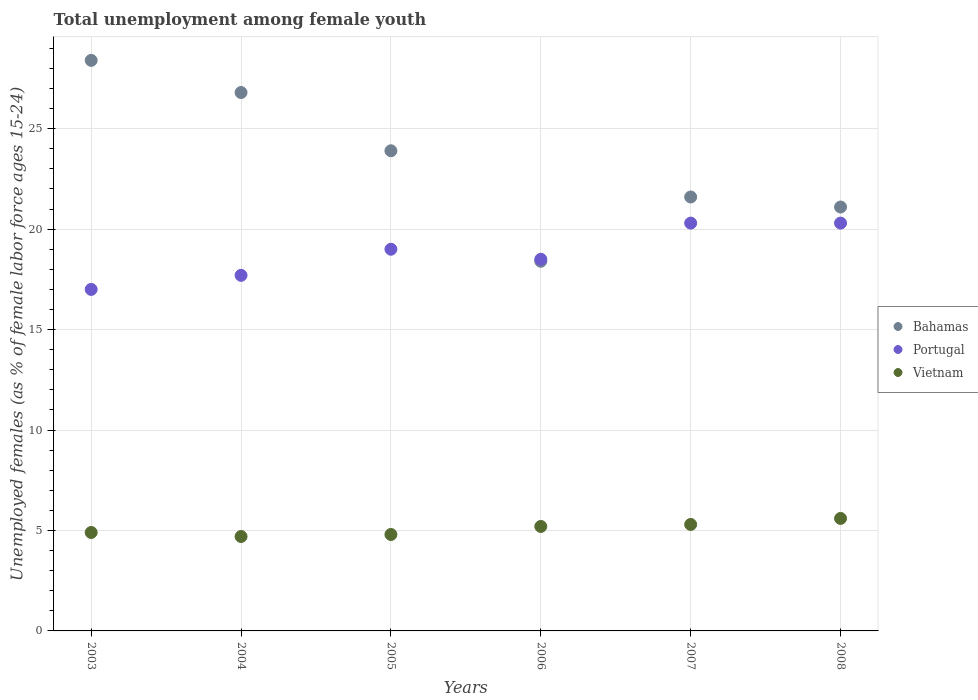What is the percentage of unemployed females in in Portugal in 2003?
Your answer should be compact. 17. Across all years, what is the maximum percentage of unemployed females in in Vietnam?
Keep it short and to the point. 5.6. Across all years, what is the minimum percentage of unemployed females in in Bahamas?
Give a very brief answer. 18.4. In which year was the percentage of unemployed females in in Vietnam maximum?
Your response must be concise. 2008. In which year was the percentage of unemployed females in in Vietnam minimum?
Your response must be concise. 2004. What is the total percentage of unemployed females in in Vietnam in the graph?
Offer a terse response. 30.5. What is the difference between the percentage of unemployed females in in Vietnam in 2004 and that in 2007?
Offer a very short reply. -0.6. What is the difference between the percentage of unemployed females in in Vietnam in 2004 and the percentage of unemployed females in in Portugal in 2008?
Your response must be concise. -15.6. What is the average percentage of unemployed females in in Portugal per year?
Make the answer very short. 18.8. In the year 2008, what is the difference between the percentage of unemployed females in in Bahamas and percentage of unemployed females in in Portugal?
Provide a succinct answer. 0.8. In how many years, is the percentage of unemployed females in in Bahamas greater than 23 %?
Give a very brief answer. 3. What is the ratio of the percentage of unemployed females in in Vietnam in 2004 to that in 2008?
Keep it short and to the point. 0.84. Is the percentage of unemployed females in in Bahamas in 2004 less than that in 2005?
Ensure brevity in your answer.  No. What is the difference between the highest and the second highest percentage of unemployed females in in Bahamas?
Provide a short and direct response. 1.6. What is the difference between the highest and the lowest percentage of unemployed females in in Portugal?
Your answer should be compact. 3.3. Is it the case that in every year, the sum of the percentage of unemployed females in in Vietnam and percentage of unemployed females in in Portugal  is greater than the percentage of unemployed females in in Bahamas?
Offer a terse response. No. Does the percentage of unemployed females in in Portugal monotonically increase over the years?
Make the answer very short. No. Is the percentage of unemployed females in in Bahamas strictly greater than the percentage of unemployed females in in Portugal over the years?
Your answer should be compact. No. How many dotlines are there?
Make the answer very short. 3. How many years are there in the graph?
Provide a succinct answer. 6. Does the graph contain grids?
Keep it short and to the point. Yes. How are the legend labels stacked?
Provide a short and direct response. Vertical. What is the title of the graph?
Give a very brief answer. Total unemployment among female youth. Does "Kyrgyz Republic" appear as one of the legend labels in the graph?
Make the answer very short. No. What is the label or title of the X-axis?
Make the answer very short. Years. What is the label or title of the Y-axis?
Offer a very short reply. Unemployed females (as % of female labor force ages 15-24). What is the Unemployed females (as % of female labor force ages 15-24) of Bahamas in 2003?
Your answer should be very brief. 28.4. What is the Unemployed females (as % of female labor force ages 15-24) of Portugal in 2003?
Offer a terse response. 17. What is the Unemployed females (as % of female labor force ages 15-24) of Vietnam in 2003?
Provide a succinct answer. 4.9. What is the Unemployed females (as % of female labor force ages 15-24) in Bahamas in 2004?
Your answer should be very brief. 26.8. What is the Unemployed females (as % of female labor force ages 15-24) in Portugal in 2004?
Your answer should be compact. 17.7. What is the Unemployed females (as % of female labor force ages 15-24) in Vietnam in 2004?
Offer a terse response. 4.7. What is the Unemployed females (as % of female labor force ages 15-24) of Bahamas in 2005?
Offer a terse response. 23.9. What is the Unemployed females (as % of female labor force ages 15-24) in Vietnam in 2005?
Make the answer very short. 4.8. What is the Unemployed females (as % of female labor force ages 15-24) in Bahamas in 2006?
Your response must be concise. 18.4. What is the Unemployed females (as % of female labor force ages 15-24) in Portugal in 2006?
Make the answer very short. 18.5. What is the Unemployed females (as % of female labor force ages 15-24) of Vietnam in 2006?
Your answer should be compact. 5.2. What is the Unemployed females (as % of female labor force ages 15-24) in Bahamas in 2007?
Provide a succinct answer. 21.6. What is the Unemployed females (as % of female labor force ages 15-24) in Portugal in 2007?
Keep it short and to the point. 20.3. What is the Unemployed females (as % of female labor force ages 15-24) of Vietnam in 2007?
Your response must be concise. 5.3. What is the Unemployed females (as % of female labor force ages 15-24) in Bahamas in 2008?
Ensure brevity in your answer.  21.1. What is the Unemployed females (as % of female labor force ages 15-24) of Portugal in 2008?
Ensure brevity in your answer.  20.3. What is the Unemployed females (as % of female labor force ages 15-24) in Vietnam in 2008?
Keep it short and to the point. 5.6. Across all years, what is the maximum Unemployed females (as % of female labor force ages 15-24) of Bahamas?
Give a very brief answer. 28.4. Across all years, what is the maximum Unemployed females (as % of female labor force ages 15-24) in Portugal?
Your answer should be very brief. 20.3. Across all years, what is the maximum Unemployed females (as % of female labor force ages 15-24) in Vietnam?
Offer a terse response. 5.6. Across all years, what is the minimum Unemployed females (as % of female labor force ages 15-24) in Bahamas?
Your answer should be very brief. 18.4. Across all years, what is the minimum Unemployed females (as % of female labor force ages 15-24) in Vietnam?
Ensure brevity in your answer.  4.7. What is the total Unemployed females (as % of female labor force ages 15-24) in Bahamas in the graph?
Ensure brevity in your answer.  140.2. What is the total Unemployed females (as % of female labor force ages 15-24) of Portugal in the graph?
Offer a terse response. 112.8. What is the total Unemployed females (as % of female labor force ages 15-24) of Vietnam in the graph?
Keep it short and to the point. 30.5. What is the difference between the Unemployed females (as % of female labor force ages 15-24) of Portugal in 2003 and that in 2004?
Offer a very short reply. -0.7. What is the difference between the Unemployed females (as % of female labor force ages 15-24) of Vietnam in 2003 and that in 2005?
Keep it short and to the point. 0.1. What is the difference between the Unemployed females (as % of female labor force ages 15-24) of Portugal in 2003 and that in 2006?
Offer a very short reply. -1.5. What is the difference between the Unemployed females (as % of female labor force ages 15-24) of Vietnam in 2003 and that in 2007?
Your answer should be very brief. -0.4. What is the difference between the Unemployed females (as % of female labor force ages 15-24) of Portugal in 2003 and that in 2008?
Give a very brief answer. -3.3. What is the difference between the Unemployed females (as % of female labor force ages 15-24) of Vietnam in 2003 and that in 2008?
Ensure brevity in your answer.  -0.7. What is the difference between the Unemployed females (as % of female labor force ages 15-24) of Portugal in 2004 and that in 2005?
Provide a succinct answer. -1.3. What is the difference between the Unemployed females (as % of female labor force ages 15-24) of Bahamas in 2004 and that in 2006?
Make the answer very short. 8.4. What is the difference between the Unemployed females (as % of female labor force ages 15-24) of Portugal in 2004 and that in 2006?
Make the answer very short. -0.8. What is the difference between the Unemployed females (as % of female labor force ages 15-24) in Bahamas in 2004 and that in 2007?
Ensure brevity in your answer.  5.2. What is the difference between the Unemployed females (as % of female labor force ages 15-24) in Portugal in 2004 and that in 2007?
Offer a terse response. -2.6. What is the difference between the Unemployed females (as % of female labor force ages 15-24) of Vietnam in 2004 and that in 2007?
Offer a very short reply. -0.6. What is the difference between the Unemployed females (as % of female labor force ages 15-24) in Bahamas in 2004 and that in 2008?
Your answer should be very brief. 5.7. What is the difference between the Unemployed females (as % of female labor force ages 15-24) in Vietnam in 2004 and that in 2008?
Offer a terse response. -0.9. What is the difference between the Unemployed females (as % of female labor force ages 15-24) in Bahamas in 2005 and that in 2006?
Offer a very short reply. 5.5. What is the difference between the Unemployed females (as % of female labor force ages 15-24) in Bahamas in 2005 and that in 2007?
Make the answer very short. 2.3. What is the difference between the Unemployed females (as % of female labor force ages 15-24) of Portugal in 2005 and that in 2007?
Offer a very short reply. -1.3. What is the difference between the Unemployed females (as % of female labor force ages 15-24) in Bahamas in 2005 and that in 2008?
Your response must be concise. 2.8. What is the difference between the Unemployed females (as % of female labor force ages 15-24) in Portugal in 2005 and that in 2008?
Make the answer very short. -1.3. What is the difference between the Unemployed females (as % of female labor force ages 15-24) of Vietnam in 2005 and that in 2008?
Provide a succinct answer. -0.8. What is the difference between the Unemployed females (as % of female labor force ages 15-24) in Portugal in 2006 and that in 2007?
Offer a terse response. -1.8. What is the difference between the Unemployed females (as % of female labor force ages 15-24) in Vietnam in 2006 and that in 2007?
Make the answer very short. -0.1. What is the difference between the Unemployed females (as % of female labor force ages 15-24) in Vietnam in 2006 and that in 2008?
Give a very brief answer. -0.4. What is the difference between the Unemployed females (as % of female labor force ages 15-24) in Bahamas in 2007 and that in 2008?
Ensure brevity in your answer.  0.5. What is the difference between the Unemployed females (as % of female labor force ages 15-24) in Bahamas in 2003 and the Unemployed females (as % of female labor force ages 15-24) in Portugal in 2004?
Ensure brevity in your answer.  10.7. What is the difference between the Unemployed females (as % of female labor force ages 15-24) in Bahamas in 2003 and the Unemployed females (as % of female labor force ages 15-24) in Vietnam in 2004?
Give a very brief answer. 23.7. What is the difference between the Unemployed females (as % of female labor force ages 15-24) in Bahamas in 2003 and the Unemployed females (as % of female labor force ages 15-24) in Vietnam in 2005?
Provide a short and direct response. 23.6. What is the difference between the Unemployed females (as % of female labor force ages 15-24) in Portugal in 2003 and the Unemployed females (as % of female labor force ages 15-24) in Vietnam in 2005?
Your answer should be compact. 12.2. What is the difference between the Unemployed females (as % of female labor force ages 15-24) of Bahamas in 2003 and the Unemployed females (as % of female labor force ages 15-24) of Portugal in 2006?
Offer a terse response. 9.9. What is the difference between the Unemployed females (as % of female labor force ages 15-24) in Bahamas in 2003 and the Unemployed females (as % of female labor force ages 15-24) in Vietnam in 2006?
Offer a very short reply. 23.2. What is the difference between the Unemployed females (as % of female labor force ages 15-24) in Bahamas in 2003 and the Unemployed females (as % of female labor force ages 15-24) in Portugal in 2007?
Your answer should be compact. 8.1. What is the difference between the Unemployed females (as % of female labor force ages 15-24) of Bahamas in 2003 and the Unemployed females (as % of female labor force ages 15-24) of Vietnam in 2007?
Ensure brevity in your answer.  23.1. What is the difference between the Unemployed females (as % of female labor force ages 15-24) in Bahamas in 2003 and the Unemployed females (as % of female labor force ages 15-24) in Vietnam in 2008?
Offer a very short reply. 22.8. What is the difference between the Unemployed females (as % of female labor force ages 15-24) of Portugal in 2003 and the Unemployed females (as % of female labor force ages 15-24) of Vietnam in 2008?
Your answer should be very brief. 11.4. What is the difference between the Unemployed females (as % of female labor force ages 15-24) of Bahamas in 2004 and the Unemployed females (as % of female labor force ages 15-24) of Portugal in 2005?
Make the answer very short. 7.8. What is the difference between the Unemployed females (as % of female labor force ages 15-24) in Bahamas in 2004 and the Unemployed females (as % of female labor force ages 15-24) in Vietnam in 2006?
Provide a short and direct response. 21.6. What is the difference between the Unemployed females (as % of female labor force ages 15-24) of Portugal in 2004 and the Unemployed females (as % of female labor force ages 15-24) of Vietnam in 2006?
Offer a terse response. 12.5. What is the difference between the Unemployed females (as % of female labor force ages 15-24) in Bahamas in 2004 and the Unemployed females (as % of female labor force ages 15-24) in Portugal in 2007?
Offer a terse response. 6.5. What is the difference between the Unemployed females (as % of female labor force ages 15-24) of Bahamas in 2004 and the Unemployed females (as % of female labor force ages 15-24) of Vietnam in 2008?
Your answer should be compact. 21.2. What is the difference between the Unemployed females (as % of female labor force ages 15-24) of Bahamas in 2005 and the Unemployed females (as % of female labor force ages 15-24) of Portugal in 2006?
Offer a terse response. 5.4. What is the difference between the Unemployed females (as % of female labor force ages 15-24) of Portugal in 2005 and the Unemployed females (as % of female labor force ages 15-24) of Vietnam in 2006?
Your answer should be compact. 13.8. What is the difference between the Unemployed females (as % of female labor force ages 15-24) of Bahamas in 2005 and the Unemployed females (as % of female labor force ages 15-24) of Vietnam in 2007?
Give a very brief answer. 18.6. What is the difference between the Unemployed females (as % of female labor force ages 15-24) in Bahamas in 2005 and the Unemployed females (as % of female labor force ages 15-24) in Portugal in 2008?
Provide a short and direct response. 3.6. What is the difference between the Unemployed females (as % of female labor force ages 15-24) of Bahamas in 2006 and the Unemployed females (as % of female labor force ages 15-24) of Vietnam in 2007?
Your answer should be compact. 13.1. What is the difference between the Unemployed females (as % of female labor force ages 15-24) in Bahamas in 2006 and the Unemployed females (as % of female labor force ages 15-24) in Portugal in 2008?
Offer a terse response. -1.9. What is the difference between the Unemployed females (as % of female labor force ages 15-24) of Bahamas in 2006 and the Unemployed females (as % of female labor force ages 15-24) of Vietnam in 2008?
Provide a succinct answer. 12.8. What is the difference between the Unemployed females (as % of female labor force ages 15-24) in Bahamas in 2007 and the Unemployed females (as % of female labor force ages 15-24) in Portugal in 2008?
Your answer should be very brief. 1.3. What is the average Unemployed females (as % of female labor force ages 15-24) in Bahamas per year?
Give a very brief answer. 23.37. What is the average Unemployed females (as % of female labor force ages 15-24) in Portugal per year?
Keep it short and to the point. 18.8. What is the average Unemployed females (as % of female labor force ages 15-24) of Vietnam per year?
Keep it short and to the point. 5.08. In the year 2003, what is the difference between the Unemployed females (as % of female labor force ages 15-24) in Bahamas and Unemployed females (as % of female labor force ages 15-24) in Portugal?
Give a very brief answer. 11.4. In the year 2003, what is the difference between the Unemployed females (as % of female labor force ages 15-24) in Bahamas and Unemployed females (as % of female labor force ages 15-24) in Vietnam?
Your response must be concise. 23.5. In the year 2004, what is the difference between the Unemployed females (as % of female labor force ages 15-24) of Bahamas and Unemployed females (as % of female labor force ages 15-24) of Vietnam?
Your answer should be compact. 22.1. In the year 2005, what is the difference between the Unemployed females (as % of female labor force ages 15-24) of Bahamas and Unemployed females (as % of female labor force ages 15-24) of Portugal?
Give a very brief answer. 4.9. In the year 2005, what is the difference between the Unemployed females (as % of female labor force ages 15-24) in Bahamas and Unemployed females (as % of female labor force ages 15-24) in Vietnam?
Your response must be concise. 19.1. In the year 2006, what is the difference between the Unemployed females (as % of female labor force ages 15-24) of Portugal and Unemployed females (as % of female labor force ages 15-24) of Vietnam?
Give a very brief answer. 13.3. In the year 2008, what is the difference between the Unemployed females (as % of female labor force ages 15-24) of Bahamas and Unemployed females (as % of female labor force ages 15-24) of Vietnam?
Your answer should be very brief. 15.5. In the year 2008, what is the difference between the Unemployed females (as % of female labor force ages 15-24) in Portugal and Unemployed females (as % of female labor force ages 15-24) in Vietnam?
Your response must be concise. 14.7. What is the ratio of the Unemployed females (as % of female labor force ages 15-24) in Bahamas in 2003 to that in 2004?
Give a very brief answer. 1.06. What is the ratio of the Unemployed females (as % of female labor force ages 15-24) of Portugal in 2003 to that in 2004?
Offer a terse response. 0.96. What is the ratio of the Unemployed females (as % of female labor force ages 15-24) of Vietnam in 2003 to that in 2004?
Offer a very short reply. 1.04. What is the ratio of the Unemployed females (as % of female labor force ages 15-24) of Bahamas in 2003 to that in 2005?
Provide a succinct answer. 1.19. What is the ratio of the Unemployed females (as % of female labor force ages 15-24) of Portugal in 2003 to that in 2005?
Offer a very short reply. 0.89. What is the ratio of the Unemployed females (as % of female labor force ages 15-24) in Vietnam in 2003 to that in 2005?
Offer a very short reply. 1.02. What is the ratio of the Unemployed females (as % of female labor force ages 15-24) of Bahamas in 2003 to that in 2006?
Your answer should be very brief. 1.54. What is the ratio of the Unemployed females (as % of female labor force ages 15-24) of Portugal in 2003 to that in 2006?
Make the answer very short. 0.92. What is the ratio of the Unemployed females (as % of female labor force ages 15-24) of Vietnam in 2003 to that in 2006?
Provide a succinct answer. 0.94. What is the ratio of the Unemployed females (as % of female labor force ages 15-24) in Bahamas in 2003 to that in 2007?
Offer a very short reply. 1.31. What is the ratio of the Unemployed females (as % of female labor force ages 15-24) of Portugal in 2003 to that in 2007?
Provide a succinct answer. 0.84. What is the ratio of the Unemployed females (as % of female labor force ages 15-24) in Vietnam in 2003 to that in 2007?
Ensure brevity in your answer.  0.92. What is the ratio of the Unemployed females (as % of female labor force ages 15-24) of Bahamas in 2003 to that in 2008?
Provide a succinct answer. 1.35. What is the ratio of the Unemployed females (as % of female labor force ages 15-24) of Portugal in 2003 to that in 2008?
Provide a succinct answer. 0.84. What is the ratio of the Unemployed females (as % of female labor force ages 15-24) of Vietnam in 2003 to that in 2008?
Your answer should be compact. 0.88. What is the ratio of the Unemployed females (as % of female labor force ages 15-24) in Bahamas in 2004 to that in 2005?
Your answer should be compact. 1.12. What is the ratio of the Unemployed females (as % of female labor force ages 15-24) in Portugal in 2004 to that in 2005?
Offer a terse response. 0.93. What is the ratio of the Unemployed females (as % of female labor force ages 15-24) of Vietnam in 2004 to that in 2005?
Keep it short and to the point. 0.98. What is the ratio of the Unemployed females (as % of female labor force ages 15-24) in Bahamas in 2004 to that in 2006?
Offer a very short reply. 1.46. What is the ratio of the Unemployed females (as % of female labor force ages 15-24) in Portugal in 2004 to that in 2006?
Offer a terse response. 0.96. What is the ratio of the Unemployed females (as % of female labor force ages 15-24) of Vietnam in 2004 to that in 2006?
Your answer should be very brief. 0.9. What is the ratio of the Unemployed females (as % of female labor force ages 15-24) in Bahamas in 2004 to that in 2007?
Ensure brevity in your answer.  1.24. What is the ratio of the Unemployed females (as % of female labor force ages 15-24) of Portugal in 2004 to that in 2007?
Offer a very short reply. 0.87. What is the ratio of the Unemployed females (as % of female labor force ages 15-24) of Vietnam in 2004 to that in 2007?
Offer a terse response. 0.89. What is the ratio of the Unemployed females (as % of female labor force ages 15-24) of Bahamas in 2004 to that in 2008?
Offer a very short reply. 1.27. What is the ratio of the Unemployed females (as % of female labor force ages 15-24) of Portugal in 2004 to that in 2008?
Your response must be concise. 0.87. What is the ratio of the Unemployed females (as % of female labor force ages 15-24) in Vietnam in 2004 to that in 2008?
Ensure brevity in your answer.  0.84. What is the ratio of the Unemployed females (as % of female labor force ages 15-24) of Bahamas in 2005 to that in 2006?
Offer a very short reply. 1.3. What is the ratio of the Unemployed females (as % of female labor force ages 15-24) of Portugal in 2005 to that in 2006?
Provide a short and direct response. 1.03. What is the ratio of the Unemployed females (as % of female labor force ages 15-24) in Bahamas in 2005 to that in 2007?
Ensure brevity in your answer.  1.11. What is the ratio of the Unemployed females (as % of female labor force ages 15-24) of Portugal in 2005 to that in 2007?
Keep it short and to the point. 0.94. What is the ratio of the Unemployed females (as % of female labor force ages 15-24) in Vietnam in 2005 to that in 2007?
Provide a short and direct response. 0.91. What is the ratio of the Unemployed females (as % of female labor force ages 15-24) of Bahamas in 2005 to that in 2008?
Make the answer very short. 1.13. What is the ratio of the Unemployed females (as % of female labor force ages 15-24) of Portugal in 2005 to that in 2008?
Make the answer very short. 0.94. What is the ratio of the Unemployed females (as % of female labor force ages 15-24) in Bahamas in 2006 to that in 2007?
Make the answer very short. 0.85. What is the ratio of the Unemployed females (as % of female labor force ages 15-24) in Portugal in 2006 to that in 2007?
Offer a very short reply. 0.91. What is the ratio of the Unemployed females (as % of female labor force ages 15-24) in Vietnam in 2006 to that in 2007?
Your response must be concise. 0.98. What is the ratio of the Unemployed females (as % of female labor force ages 15-24) in Bahamas in 2006 to that in 2008?
Ensure brevity in your answer.  0.87. What is the ratio of the Unemployed females (as % of female labor force ages 15-24) of Portugal in 2006 to that in 2008?
Your response must be concise. 0.91. What is the ratio of the Unemployed females (as % of female labor force ages 15-24) in Vietnam in 2006 to that in 2008?
Your answer should be compact. 0.93. What is the ratio of the Unemployed females (as % of female labor force ages 15-24) in Bahamas in 2007 to that in 2008?
Make the answer very short. 1.02. What is the ratio of the Unemployed females (as % of female labor force ages 15-24) in Portugal in 2007 to that in 2008?
Provide a short and direct response. 1. What is the ratio of the Unemployed females (as % of female labor force ages 15-24) of Vietnam in 2007 to that in 2008?
Ensure brevity in your answer.  0.95. What is the difference between the highest and the lowest Unemployed females (as % of female labor force ages 15-24) in Vietnam?
Offer a very short reply. 0.9. 